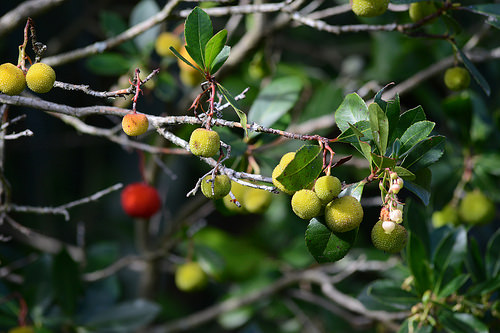<image>
Is there a leaf above the fruit? Yes. The leaf is positioned above the fruit in the vertical space, higher up in the scene. 